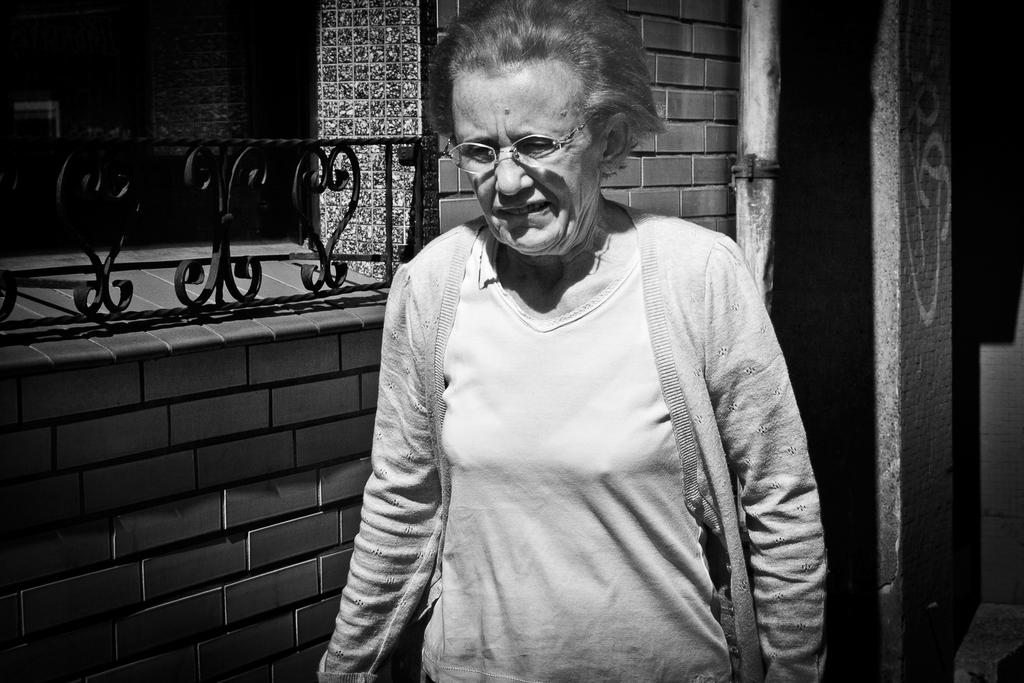What is the color scheme of the image? The image is in black and white. Who is the main subject in the image? There is an old woman in the image. What is the old woman wearing? The old woman is wearing a shirt and a jacket. What accessory does the old woman have? The old woman has spectacles. What can be seen on the left side of the image? There is a brick wall on the left side of the image. What is the color of the grills on the brick wall? The brick wall has black color grills. What is the old woman's father doing in the image? There is no mention of the old woman's father in the image, so we cannot answer that question. Is the old woman reading a book in the image? There is no book visible in the image, so we cannot determine if the old woman is reading. 